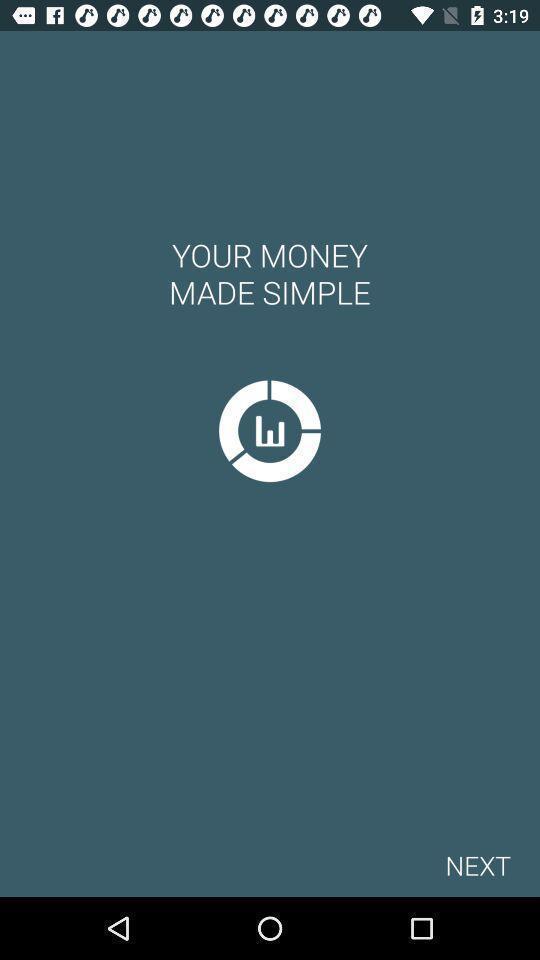What is the overall content of this screenshot? Welcome page of a financial app. 